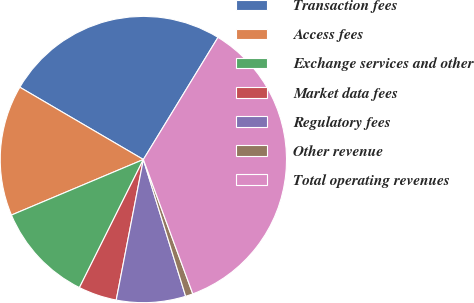<chart> <loc_0><loc_0><loc_500><loc_500><pie_chart><fcel>Transaction fees<fcel>Access fees<fcel>Exchange services and other<fcel>Market data fees<fcel>Regulatory fees<fcel>Other revenue<fcel>Total operating revenues<nl><fcel>25.3%<fcel>14.77%<fcel>11.29%<fcel>4.33%<fcel>7.81%<fcel>0.84%<fcel>35.66%<nl></chart> 